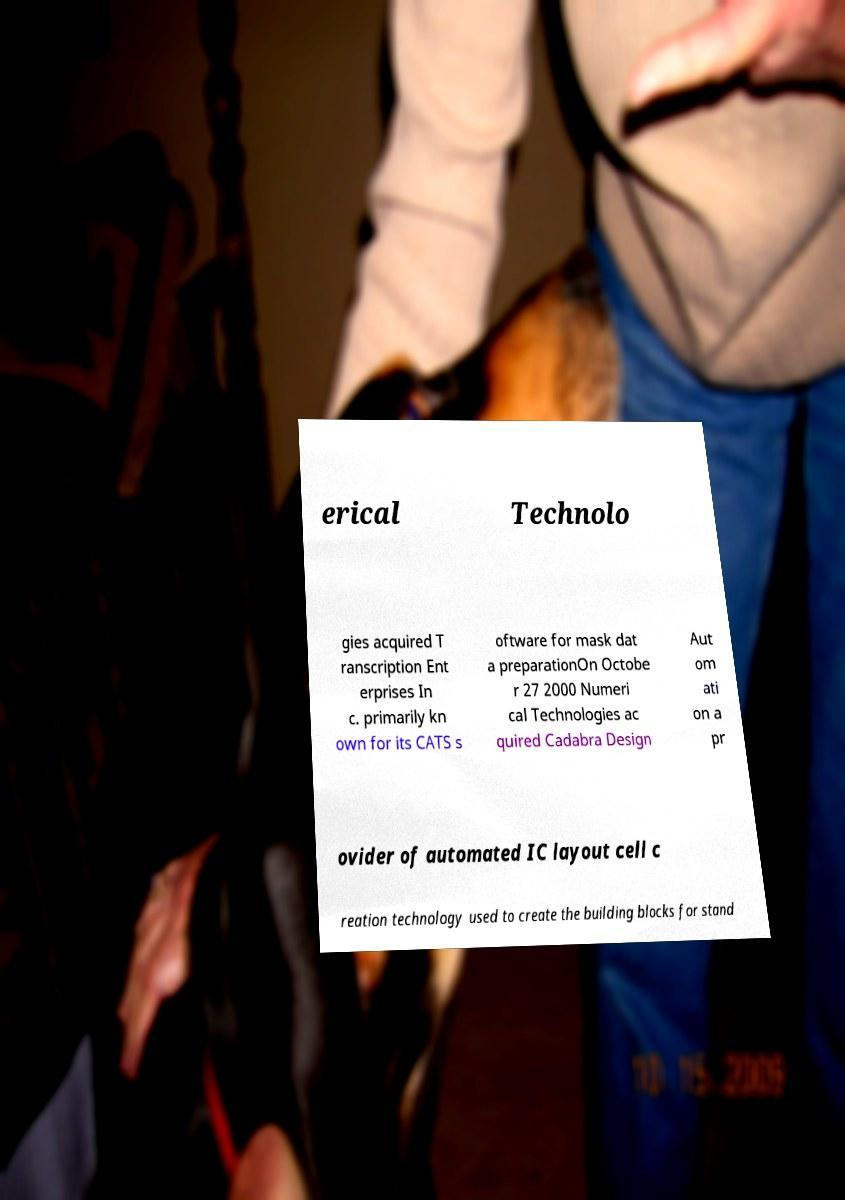Could you extract and type out the text from this image? erical Technolo gies acquired T ranscription Ent erprises In c. primarily kn own for its CATS s oftware for mask dat a preparationOn Octobe r 27 2000 Numeri cal Technologies ac quired Cadabra Design Aut om ati on a pr ovider of automated IC layout cell c reation technology used to create the building blocks for stand 